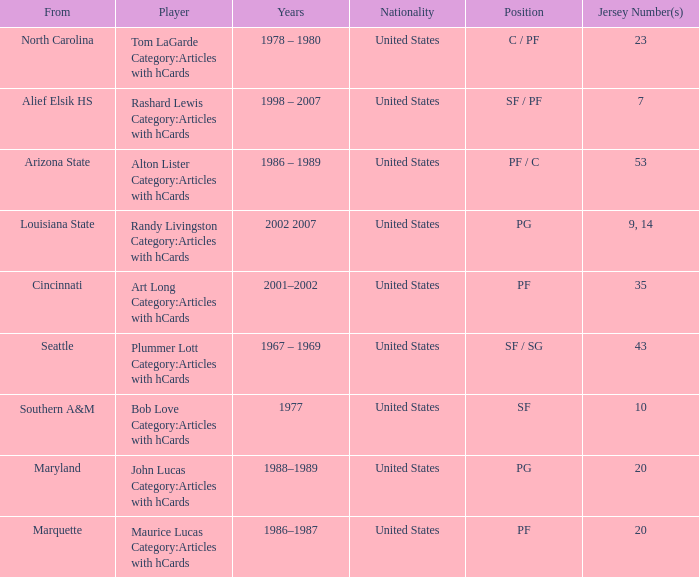Alton Lister Category:Articles with hCards has what as the listed years? 1986 – 1989. Parse the table in full. {'header': ['From', 'Player', 'Years', 'Nationality', 'Position', 'Jersey Number(s)'], 'rows': [['North Carolina', 'Tom LaGarde Category:Articles with hCards', '1978 – 1980', 'United States', 'C / PF', '23'], ['Alief Elsik HS', 'Rashard Lewis Category:Articles with hCards', '1998 – 2007', 'United States', 'SF / PF', '7'], ['Arizona State', 'Alton Lister Category:Articles with hCards', '1986 – 1989', 'United States', 'PF / C', '53'], ['Louisiana State', 'Randy Livingston Category:Articles with hCards', '2002 2007', 'United States', 'PG', '9, 14'], ['Cincinnati', 'Art Long Category:Articles with hCards', '2001–2002', 'United States', 'PF', '35'], ['Seattle', 'Plummer Lott Category:Articles with hCards', '1967 – 1969', 'United States', 'SF / SG', '43'], ['Southern A&M', 'Bob Love Category:Articles with hCards', '1977', 'United States', 'SF', '10'], ['Maryland', 'John Lucas Category:Articles with hCards', '1988–1989', 'United States', 'PG', '20'], ['Marquette', 'Maurice Lucas Category:Articles with hCards', '1986–1987', 'United States', 'PF', '20']]} 